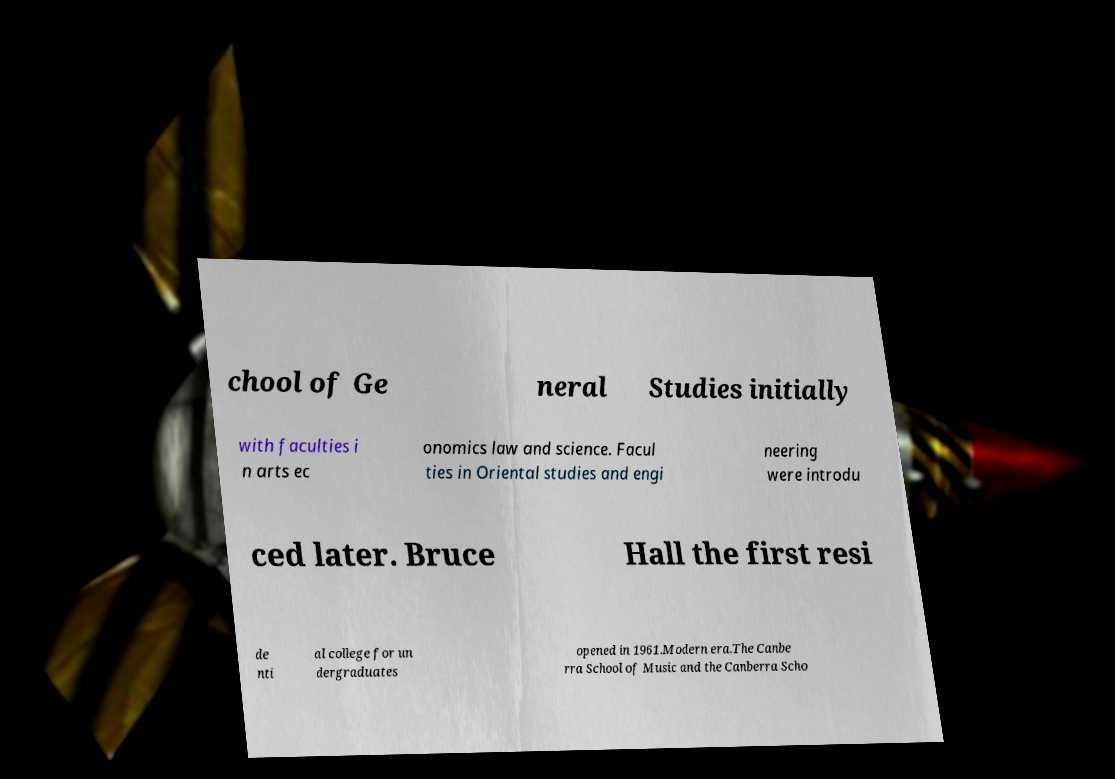Please read and relay the text visible in this image. What does it say? chool of Ge neral Studies initially with faculties i n arts ec onomics law and science. Facul ties in Oriental studies and engi neering were introdu ced later. Bruce Hall the first resi de nti al college for un dergraduates opened in 1961.Modern era.The Canbe rra School of Music and the Canberra Scho 